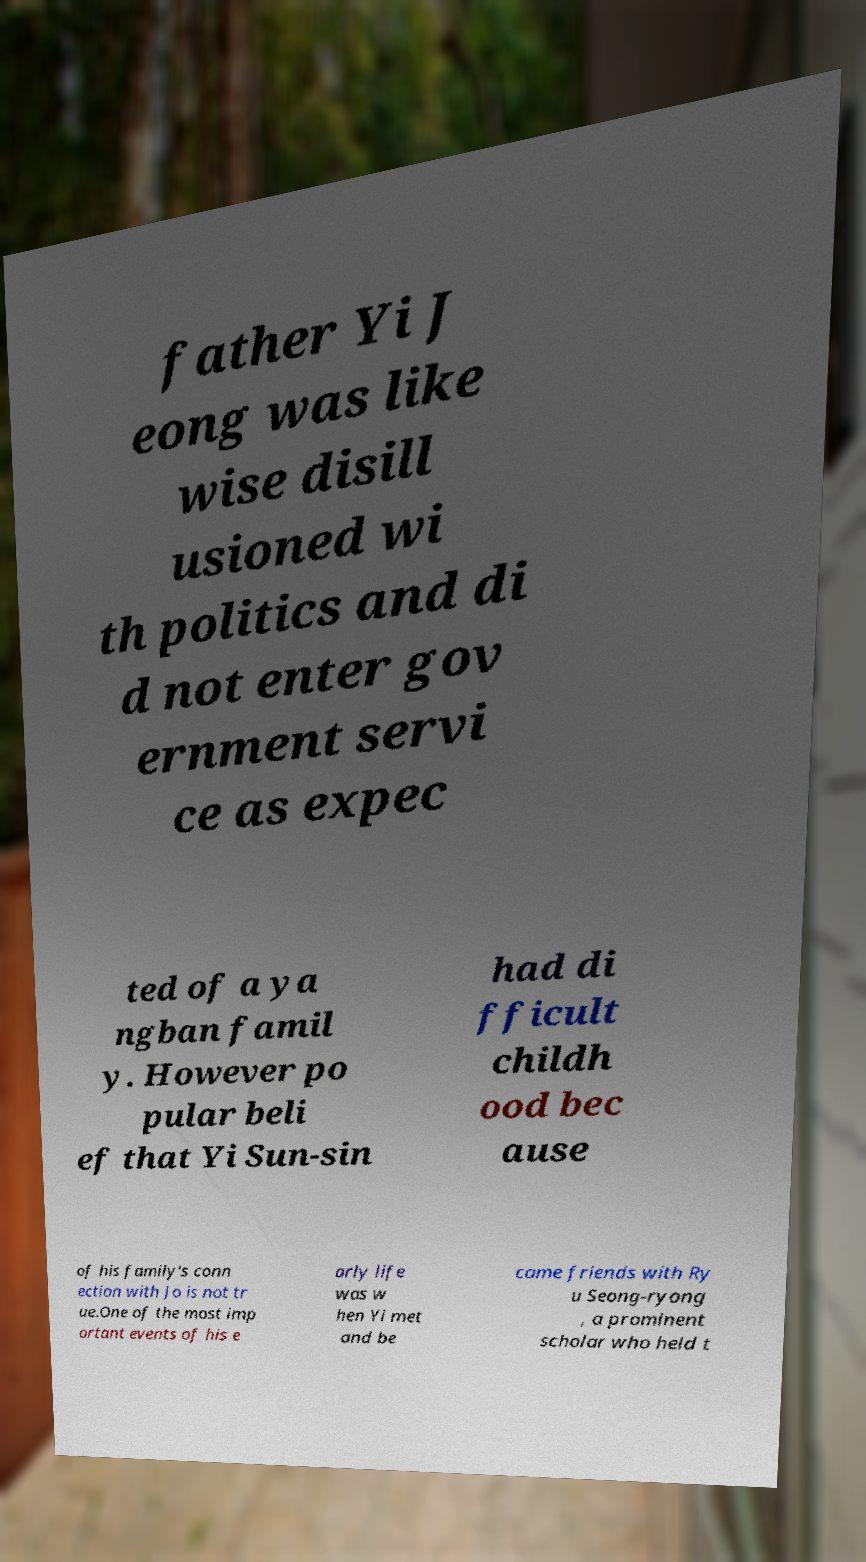Please identify and transcribe the text found in this image. father Yi J eong was like wise disill usioned wi th politics and di d not enter gov ernment servi ce as expec ted of a ya ngban famil y. However po pular beli ef that Yi Sun-sin had di fficult childh ood bec ause of his family's conn ection with Jo is not tr ue.One of the most imp ortant events of his e arly life was w hen Yi met and be came friends with Ry u Seong-ryong , a prominent scholar who held t 